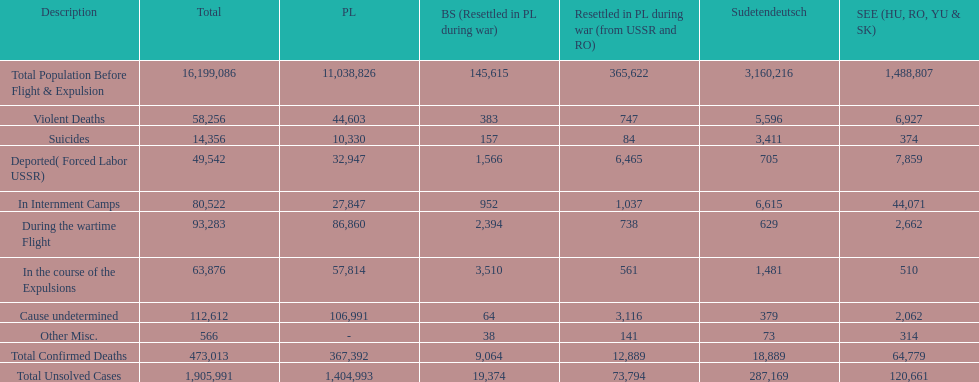Which country had the larger death tole? Poland. 